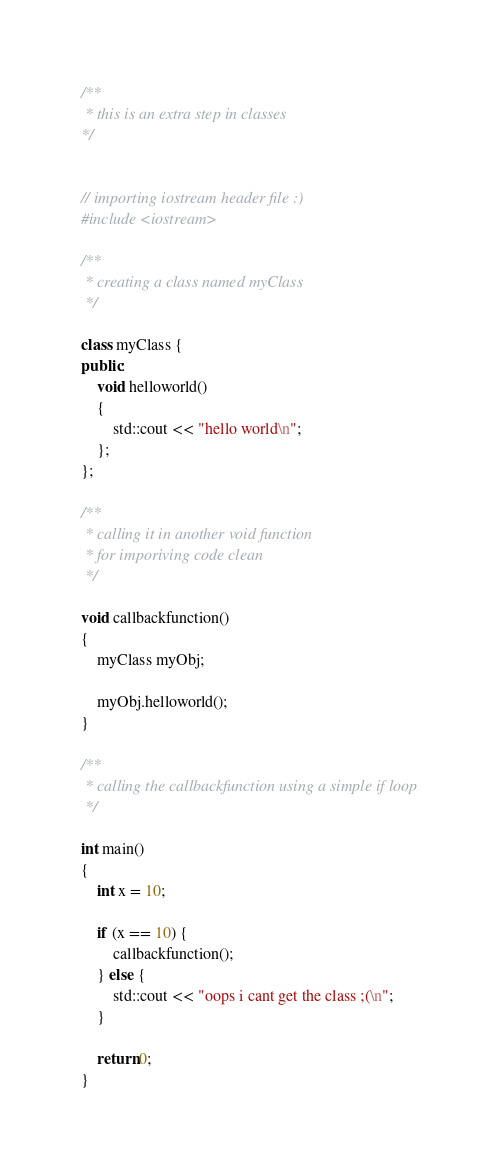Convert code to text. <code><loc_0><loc_0><loc_500><loc_500><_C++_>/**
 * this is an extra step in classes
*/


// importing iostream header file :) 
#include <iostream>

/**
 * creating a class named myClass
 */ 

class myClass {
public:
	void helloworld()
	{
		std::cout << "hello world\n";
	};
};

/**
 * calling it in another void function
 * for imporiving code clean
 */

void callbackfunction()
{
	myClass myObj;

	myObj.helloworld();
}

/**
 * calling the callbackfunction using a simple if loop
 */

int main()
{
	int x = 10;

	if (x == 10) {
		callbackfunction();
	} else {
		std::cout << "oops i cant get the class ;(\n";
	}

	return 0;
}</code> 